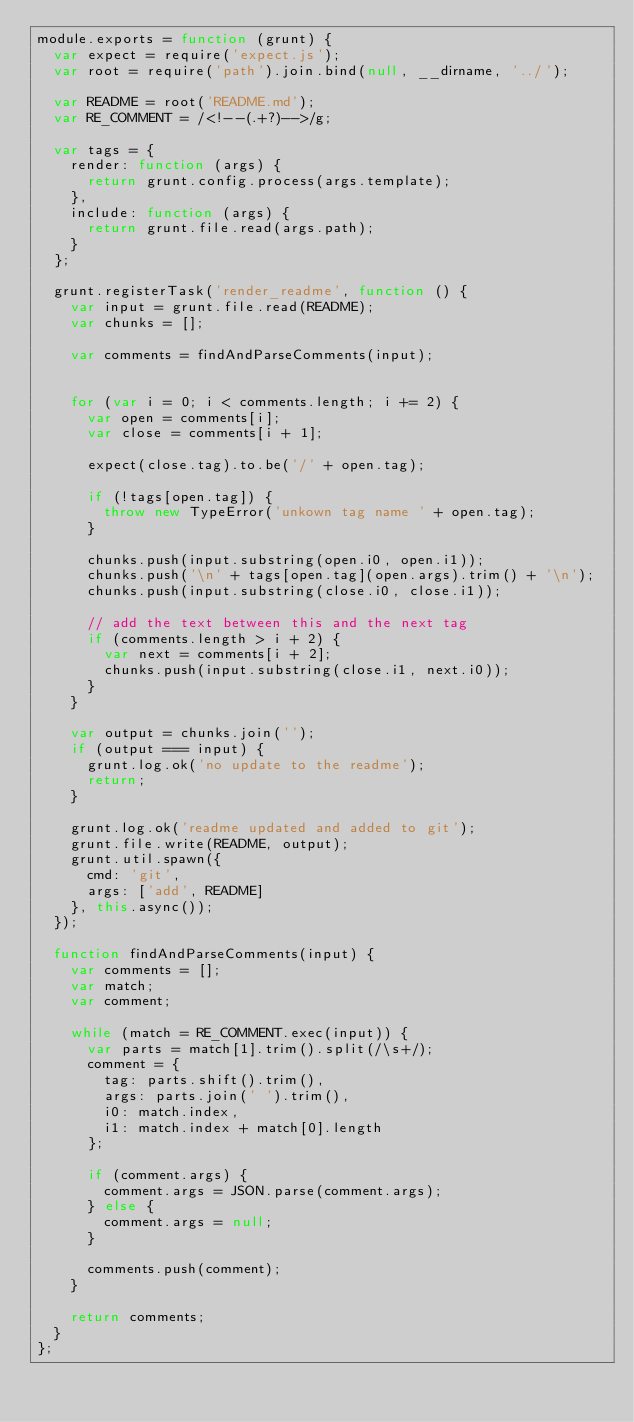Convert code to text. <code><loc_0><loc_0><loc_500><loc_500><_JavaScript_>module.exports = function (grunt) {
  var expect = require('expect.js');
  var root = require('path').join.bind(null, __dirname, '../');

  var README = root('README.md');
  var RE_COMMENT = /<!--(.+?)-->/g;

  var tags = {
    render: function (args) {
      return grunt.config.process(args.template);
    },
    include: function (args) {
      return grunt.file.read(args.path);
    }
  };

  grunt.registerTask('render_readme', function () {
    var input = grunt.file.read(README);
    var chunks = [];

    var comments = findAndParseComments(input);


    for (var i = 0; i < comments.length; i += 2) {
      var open = comments[i];
      var close = comments[i + 1];

      expect(close.tag).to.be('/' + open.tag);

      if (!tags[open.tag]) {
        throw new TypeError('unkown tag name ' + open.tag);
      }

      chunks.push(input.substring(open.i0, open.i1));
      chunks.push('\n' + tags[open.tag](open.args).trim() + '\n');
      chunks.push(input.substring(close.i0, close.i1));

      // add the text between this and the next tag
      if (comments.length > i + 2) {
        var next = comments[i + 2];
        chunks.push(input.substring(close.i1, next.i0));
      }
    }

    var output = chunks.join('');
    if (output === input) {
      grunt.log.ok('no update to the readme');
      return;
    }

    grunt.log.ok('readme updated and added to git');
    grunt.file.write(README, output);
    grunt.util.spawn({
      cmd: 'git',
      args: ['add', README]
    }, this.async());
  });

  function findAndParseComments(input) {
    var comments = [];
    var match;
    var comment;

    while (match = RE_COMMENT.exec(input)) {
      var parts = match[1].trim().split(/\s+/);
      comment = {
        tag: parts.shift().trim(),
        args: parts.join(' ').trim(),
        i0: match.index,
        i1: match.index + match[0].length
      };

      if (comment.args) {
        comment.args = JSON.parse(comment.args);
      } else {
        comment.args = null;
      }

      comments.push(comment);
    }

    return comments;
  }
};
</code> 